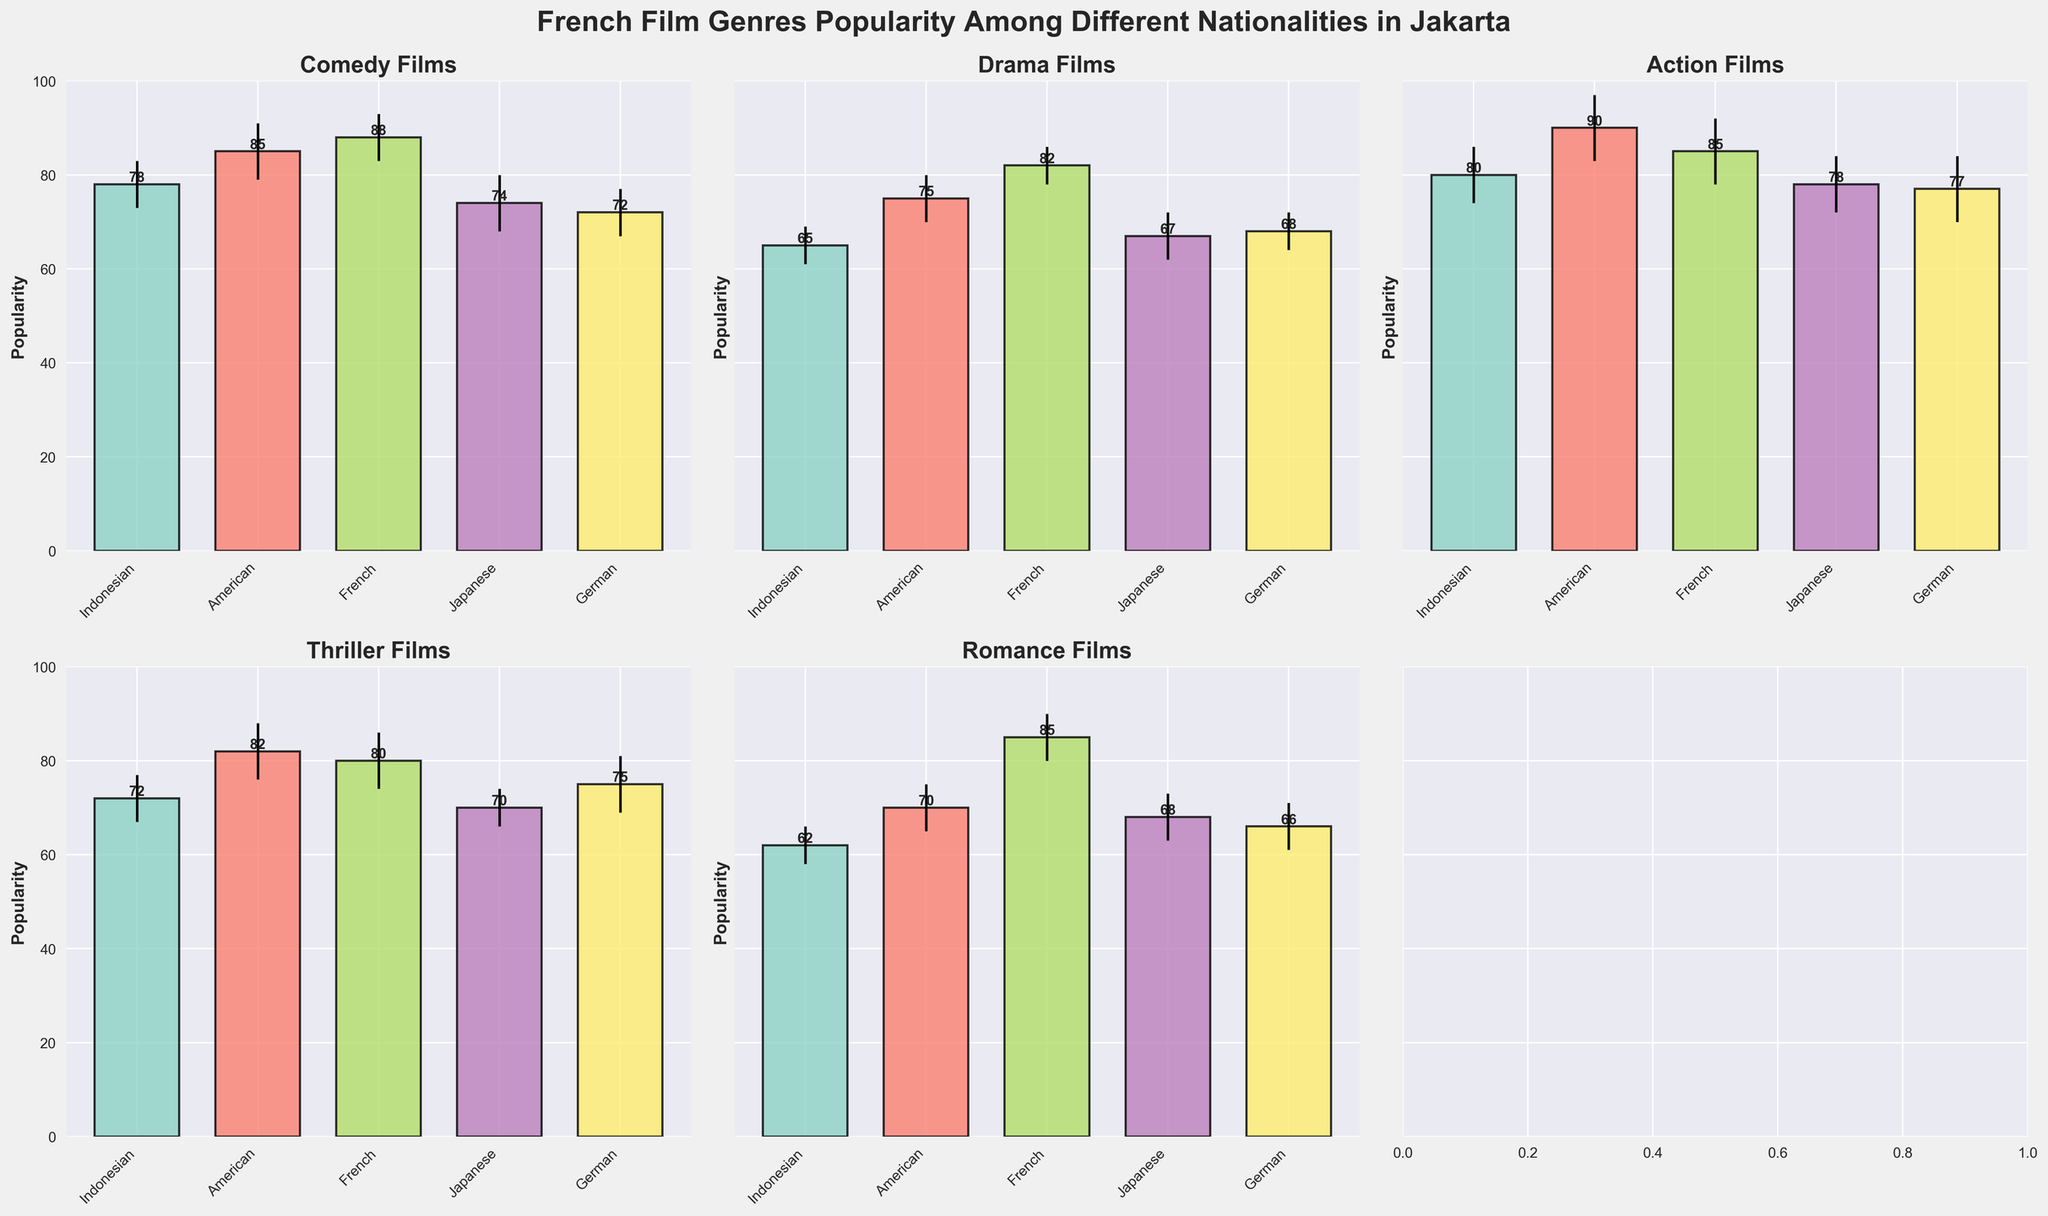What is the title of the figure? The title of the figure is placed at the top and describes what the entire chart is about. Reading the title, we see: 'French Film Genres Popularity Among Different Nationalities in Jakarta'
Answer: 'French Film Genres Popularity Among Different Nationalities in Jakarta' How many different nationalities are represented in the figure? Each genre subplot lists the nationalities. There are five nationalities: Indonesian, American, French, Japanese, and German.
Answer: Five Which genre of French films is the least popular among Germans? The heights of the bars indicate popularity. In the subplot for Germans, Romance has the lowest bar with a popularity of 66.
Answer: Romance Which nationality has the highest preference for French Comedy films? Looking at the Comedy subplot, the French nationality has the highest bar with a value of 88.
Answer: French Which genre of French films do Americans prefer the most? In the subplot for Americans, Action has the highest bar with a value of 90.
Answer: Action What is the difference in popularity between French and Japanese preferences for French Action films? From the Action subplot, the popularity for French is 85, and for Japanese, it’s 78. The difference is 85 - 78 = 7.
Answer: 7 Which French film genre has the highest average popularity across all nationalities? Calculating the average for each genre:
Comedy: (78 + 85 + 88 + 74 + 72) / 5 = 79.4
Drama: (65 + 75 + 82 + 67 + 68) / 5 = 71.4
Action: (80 + 90 + 85 + 78 + 77) / 5 = 82
Thriller: (72 + 82 + 80 + 70 + 75) / 5 = 75.8
Romance: (62 + 70 + 85 + 68 + 66) / 5 = 70.2
Action films have the highest average popularity (82).
Answer: Action Which nationality has the least preference for French Thriller films? In the Thriller subplot, the bar for Japanese is the lowest with a popularity of 70.
Answer: Japanese How does the popularity of French Romance films compare between Indonesians and French nationals? In the Romance subplot, Indonesians have a popularity of 62 and the French have 85. The French much prefer Romance films compared to Indonesians.
Answer: The French prefer Romance films more Which genre has the largest error margin for any nationality? Observing all subplots, Action (German) has the largest margin of error at 7.
Answer: Action (German) 